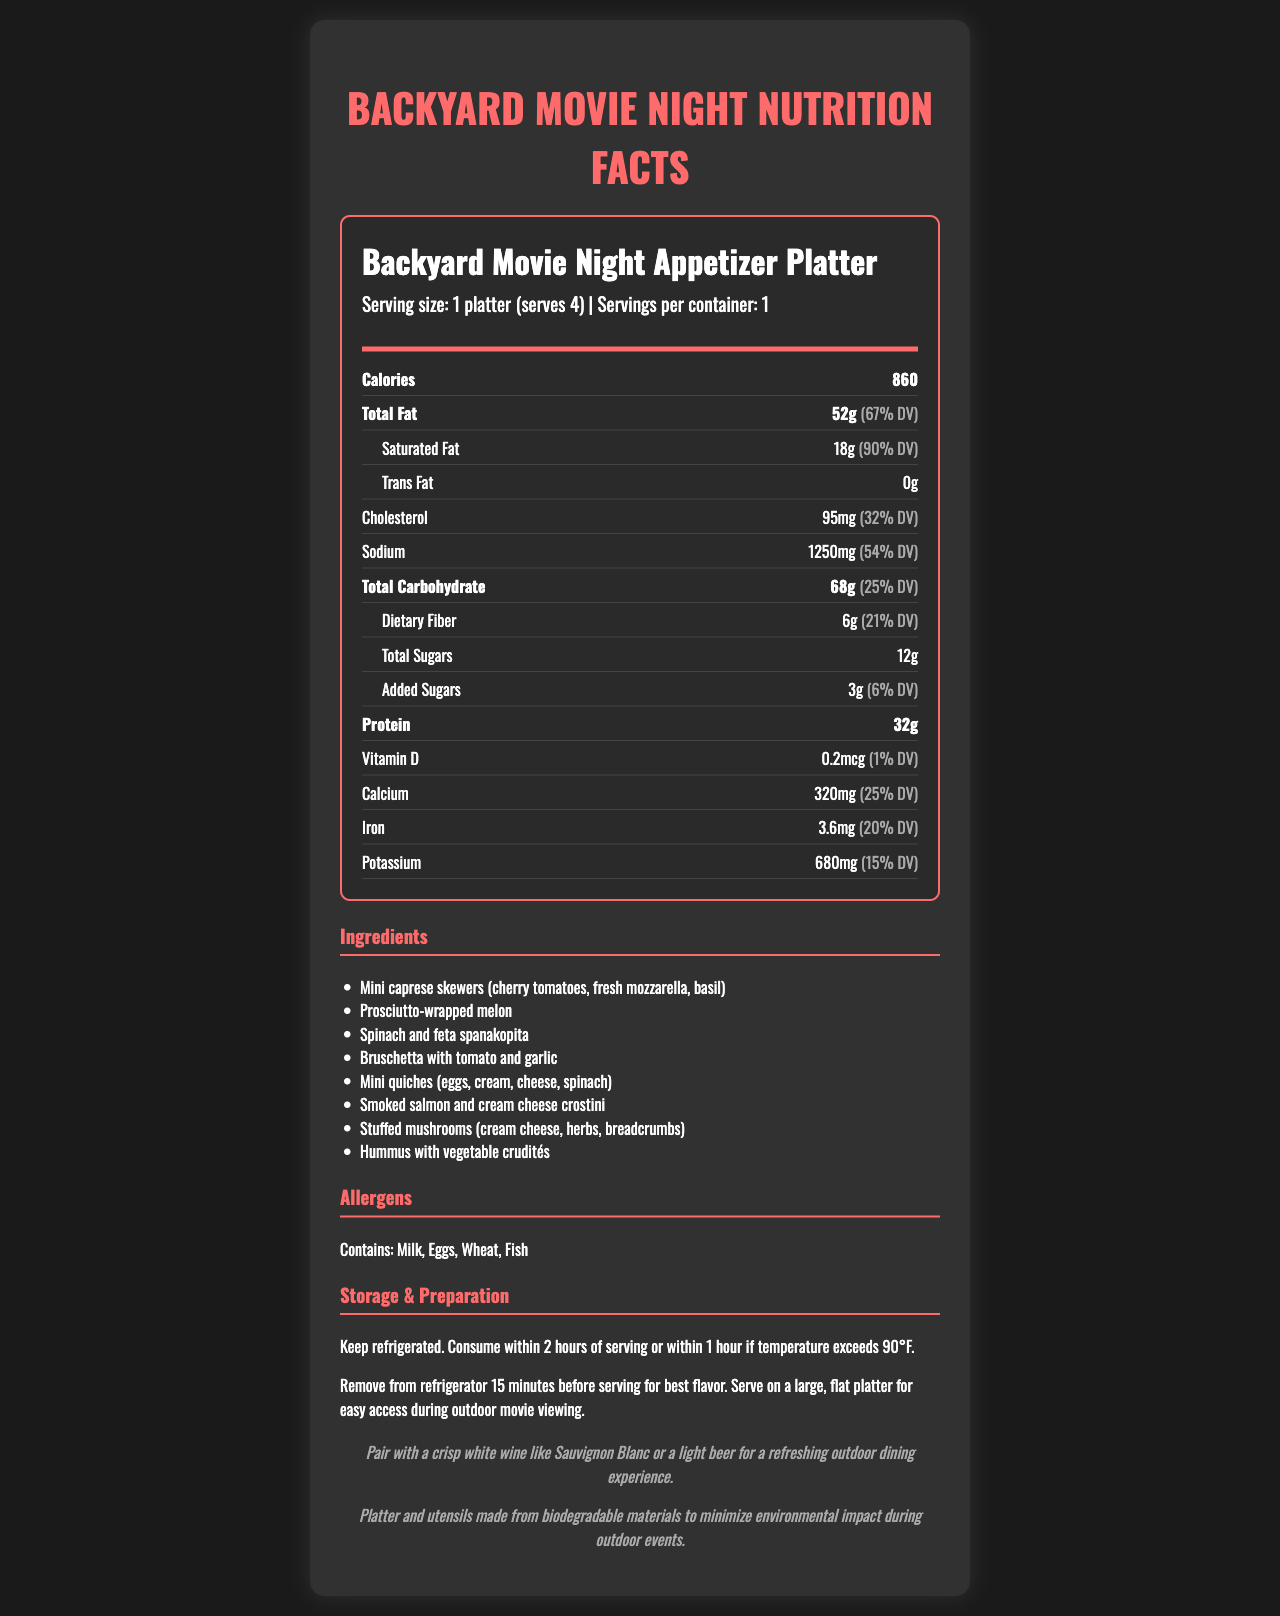how many grams of total fat does the platter have? The document states that the platter has a total fat content of 52 grams.
Answer: 52 grams what is the daily value percentage for saturated fat? The daily value percentage for saturated fat is displayed as 90%.
Answer: 90% how many servings are there per container? The serving information specifies that there are 1 serving per container.
Answer: 1 how much calcium is in the platter? The document lists the calcium content as 320 mg.
Answer: 320 mg which allergen is NOT listed in the platter? A. Milk B. Eggs C. Fish D. Peanuts The allergens listed are Milk, Eggs, Wheat, and Fish. Peanuts are not listed.
Answer: D. Peanuts what type of utensil material is used for the platter? The sustainability note indicates that the platter and utensils are made from biodegradable materials.
Answer: Biodegradable materials how should the platter be stored before serving? The storage instructions advise keeping the platter refrigerated.
Answer: Keep refrigerated what pairing suggestion is mentioned for drinks? The pairing suggestion in the document recommends pairing the platter with a crisp white wine like Sauvignon Blanc or a light beer.
Answer: Sauvignon Blanc or a light beer how much cholesterol is in the platter? The document states that the platter contains 95 mg of cholesterol.
Answer: 95 mg does the platter contain any trans fat? The document specifies that the platter contains 0 grams of trans fat.
Answer: No does the platter have any added sugars? The platter contains 3 grams of added sugars.
Answer: Yes describe the main idea of the document. The document lists nutritional information, ingredients, allergens, storage, and preparation tips for the appetizer platter intended for outdoor movie events, along with pairing suggestions and sustainability notes.
Answer: The document provides detailed nutrition facts, ingredients, and additional information about a Backyard Movie Night Appetizer Platter, designed for easy outdoor dining. what is the exact amount of vitamin D in the platter? The document specifies that the platter contains 0.2 mcg of vitamin D.
Answer: 0.2 mcg how many different appetizers are included in the platter? The ingredients list shows eight different appetizers included in the platter.
Answer: 8 how many grams of dietary fiber are there in a serving of the platter? The document lists 6 grams of dietary fiber per serving.
Answer: 6 grams what is the source of potassium in the platter? The document provides the amount of potassium (680 mg) but does not specify the source of potassium in the platter.
Answer: Not enough information 